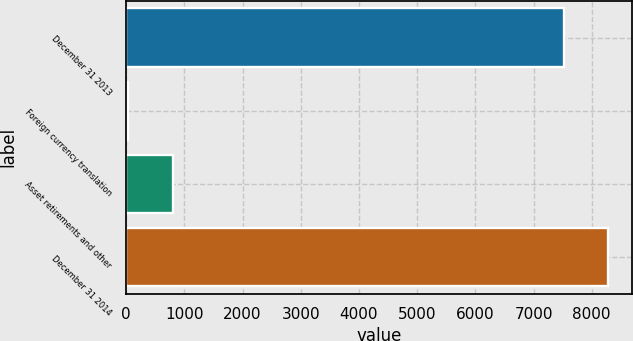Convert chart. <chart><loc_0><loc_0><loc_500><loc_500><bar_chart><fcel>December 31 2013<fcel>Foreign currency translation<fcel>Asset retirements and other<fcel>December 31 2014<nl><fcel>7518<fcel>34<fcel>799.6<fcel>8283.6<nl></chart> 